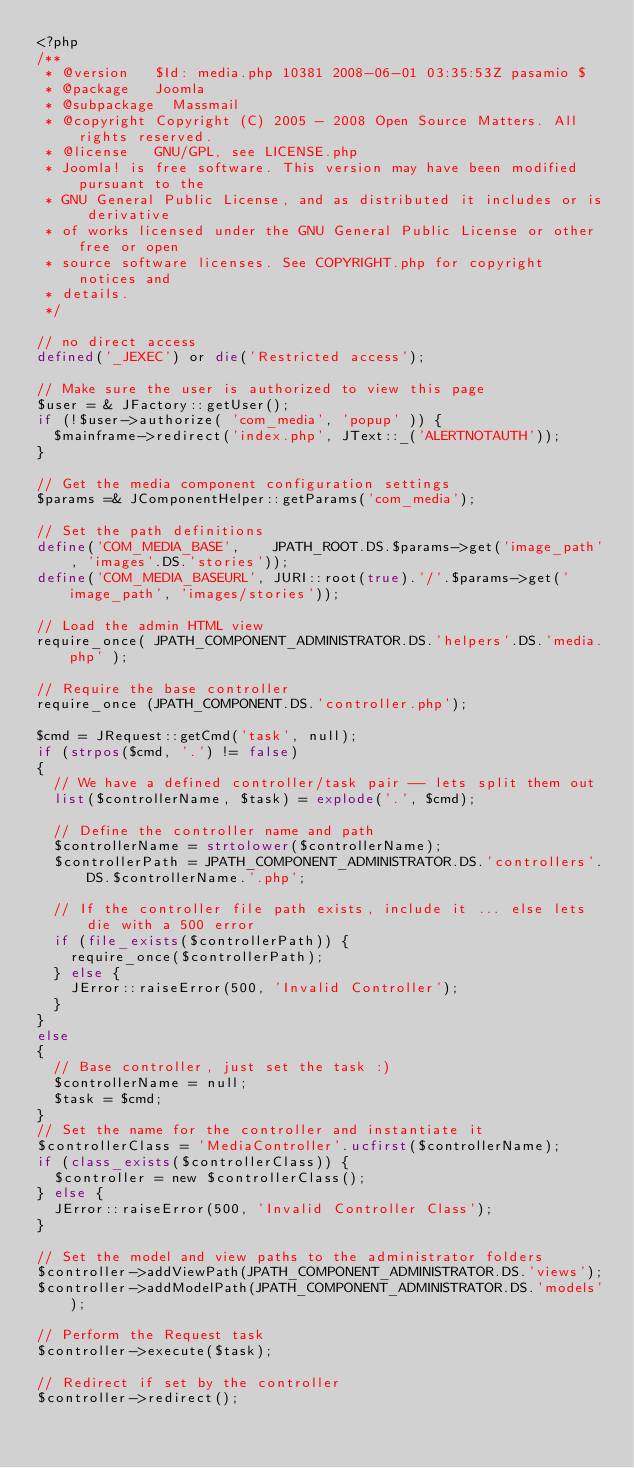Convert code to text. <code><loc_0><loc_0><loc_500><loc_500><_PHP_><?php
/**
 * @version		$Id: media.php 10381 2008-06-01 03:35:53Z pasamio $
 * @package		Joomla
 * @subpackage	Massmail
 * @copyright	Copyright (C) 2005 - 2008 Open Source Matters. All rights reserved.
 * @license		GNU/GPL, see LICENSE.php
 * Joomla! is free software. This version may have been modified pursuant to the
 * GNU General Public License, and as distributed it includes or is derivative
 * of works licensed under the GNU General Public License or other free or open
 * source software licenses. See COPYRIGHT.php for copyright notices and
 * details.
 */

// no direct access
defined('_JEXEC') or die('Restricted access');

// Make sure the user is authorized to view this page
$user = & JFactory::getUser();
if (!$user->authorize( 'com_media', 'popup' )) {
	$mainframe->redirect('index.php', JText::_('ALERTNOTAUTH'));
}

// Get the media component configuration settings
$params =& JComponentHelper::getParams('com_media');

// Set the path definitions
define('COM_MEDIA_BASE',    JPATH_ROOT.DS.$params->get('image_path', 'images'.DS.'stories'));
define('COM_MEDIA_BASEURL', JURI::root(true).'/'.$params->get('image_path', 'images/stories'));

// Load the admin HTML view
require_once( JPATH_COMPONENT_ADMINISTRATOR.DS.'helpers'.DS.'media.php' );

// Require the base controller
require_once (JPATH_COMPONENT.DS.'controller.php');

$cmd = JRequest::getCmd('task', null);
if (strpos($cmd, '.') != false)
{
	// We have a defined controller/task pair -- lets split them out
	list($controllerName, $task) = explode('.', $cmd);

	// Define the controller name and path
	$controllerName	= strtolower($controllerName);
	$controllerPath	= JPATH_COMPONENT_ADMINISTRATOR.DS.'controllers'.DS.$controllerName.'.php';

	// If the controller file path exists, include it ... else lets die with a 500 error
	if (file_exists($controllerPath)) {
		require_once($controllerPath);
	} else {
		JError::raiseError(500, 'Invalid Controller');
	}
}
else
{
	// Base controller, just set the task :)
	$controllerName = null;
	$task = $cmd;
}
// Set the name for the controller and instantiate it
$controllerClass = 'MediaController'.ucfirst($controllerName);
if (class_exists($controllerClass)) {
	$controller = new $controllerClass();
} else {
	JError::raiseError(500, 'Invalid Controller Class');
}

// Set the model and view paths to the administrator folders
$controller->addViewPath(JPATH_COMPONENT_ADMINISTRATOR.DS.'views');
$controller->addModelPath(JPATH_COMPONENT_ADMINISTRATOR.DS.'models');

// Perform the Request task
$controller->execute($task);

// Redirect if set by the controller
$controller->redirect();
</code> 